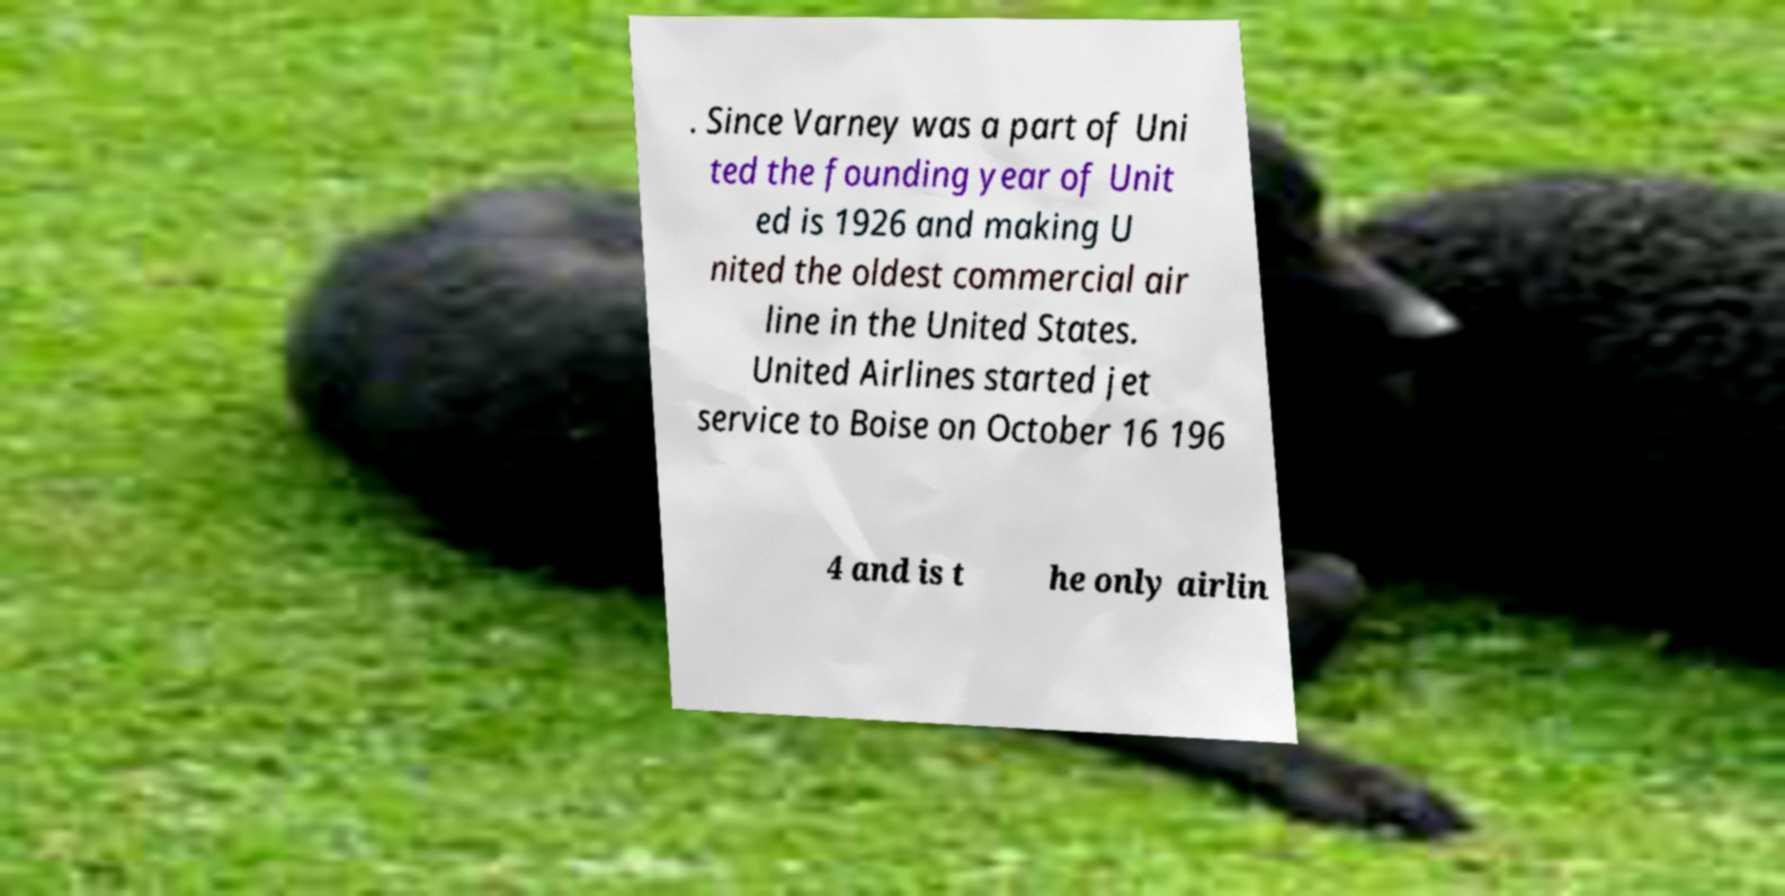There's text embedded in this image that I need extracted. Can you transcribe it verbatim? . Since Varney was a part of Uni ted the founding year of Unit ed is 1926 and making U nited the oldest commercial air line in the United States. United Airlines started jet service to Boise on October 16 196 4 and is t he only airlin 